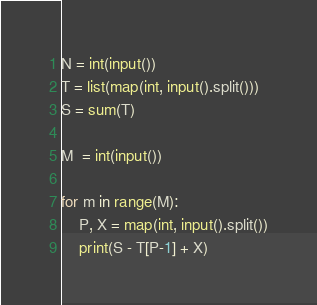<code> <loc_0><loc_0><loc_500><loc_500><_Python_>N = int(input())
T = list(map(int, input().split()))
S = sum(T)

M  = int(input())

for m in range(M):
    P, X = map(int, input().split())
    print(S - T[P-1] + X)
</code> 